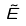<formula> <loc_0><loc_0><loc_500><loc_500>\tilde { E }</formula> 